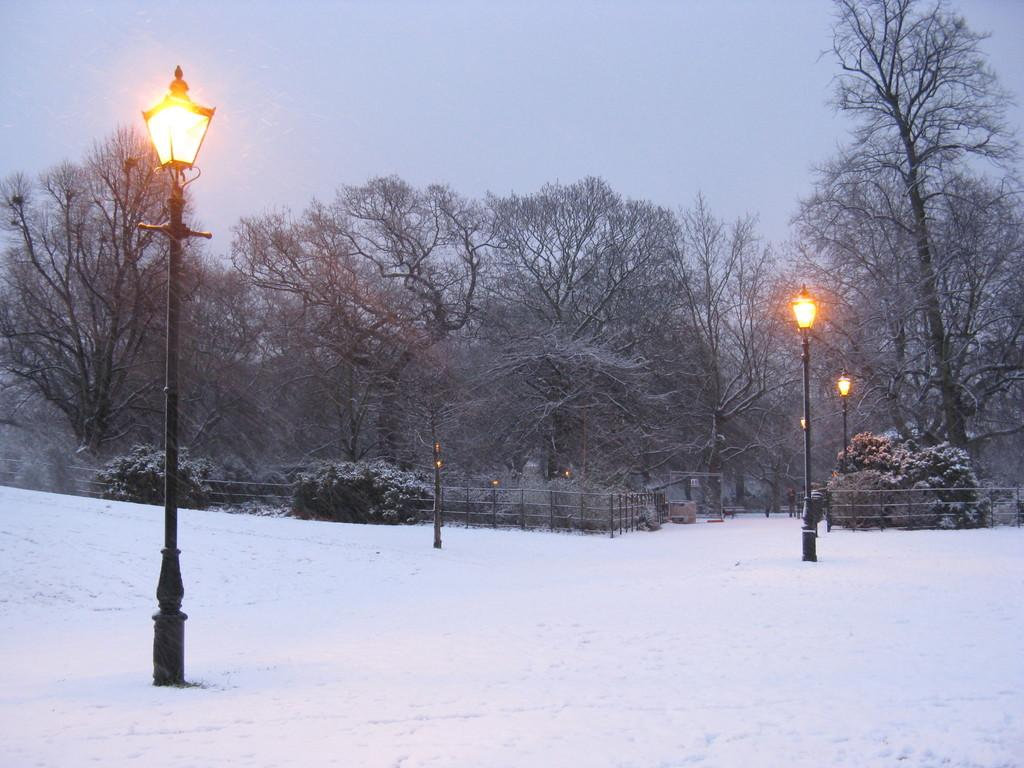What type of surface is shown in the image? The image shows a snow surface. What structures are present in the image? There are lamps on poles in the image. What can be seen in the background of the image? In the background, there is railing, plants, trees with snow on them, and the sky. What type of knowledge does the woman in the image possess? There is no woman present in the image, so it is not possible to determine what type of knowledge she might possess. 